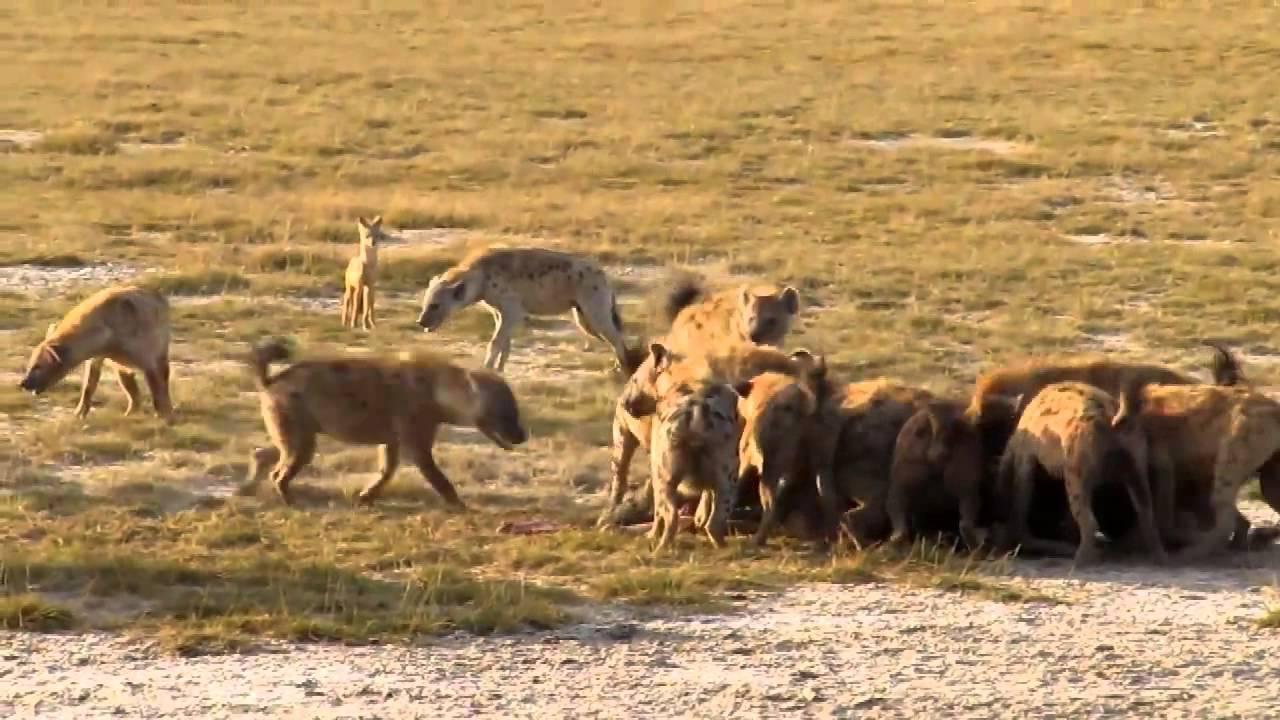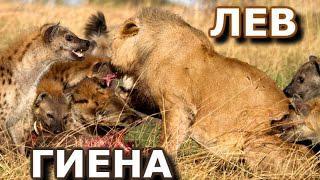The first image is the image on the left, the second image is the image on the right. For the images shown, is this caption "An image shows many 'smiling' hyenas with upraised heads around a carcass with ribs showing." true? Answer yes or no. No. The first image is the image on the left, the second image is the image on the right. Given the left and right images, does the statement "A lion is bleeding in one of the images." hold true? Answer yes or no. No. 